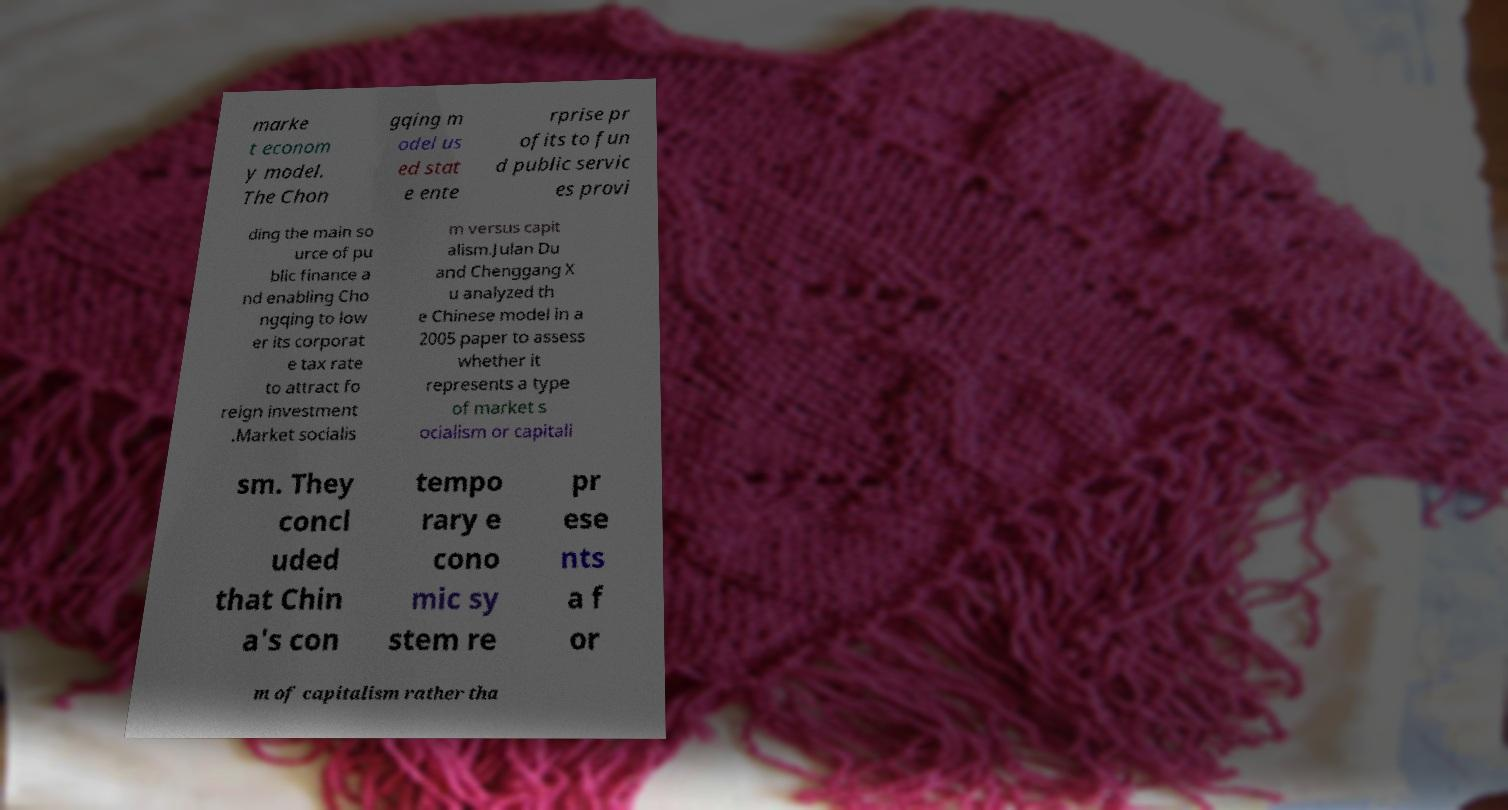For documentation purposes, I need the text within this image transcribed. Could you provide that? marke t econom y model. The Chon gqing m odel us ed stat e ente rprise pr ofits to fun d public servic es provi ding the main so urce of pu blic finance a nd enabling Cho ngqing to low er its corporat e tax rate to attract fo reign investment .Market socialis m versus capit alism.Julan Du and Chenggang X u analyzed th e Chinese model in a 2005 paper to assess whether it represents a type of market s ocialism or capitali sm. They concl uded that Chin a's con tempo rary e cono mic sy stem re pr ese nts a f or m of capitalism rather tha 